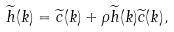Convert formula to latex. <formula><loc_0><loc_0><loc_500><loc_500>\widetilde { h } ( k ) = \widetilde { c } ( k ) + \rho \widetilde { h } ( k ) \widetilde { c } ( k ) ,</formula> 